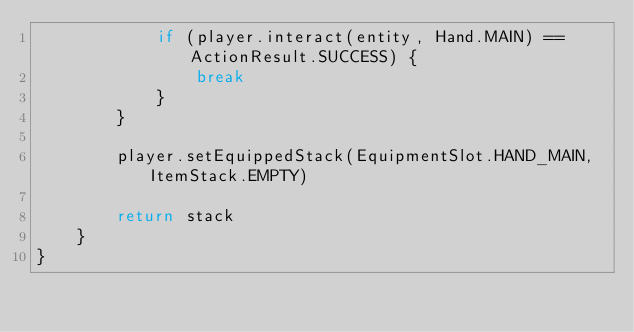<code> <loc_0><loc_0><loc_500><loc_500><_Kotlin_>            if (player.interact(entity, Hand.MAIN) == ActionResult.SUCCESS) {
                break
            }
        }

        player.setEquippedStack(EquipmentSlot.HAND_MAIN, ItemStack.EMPTY)

        return stack
    }
}
</code> 